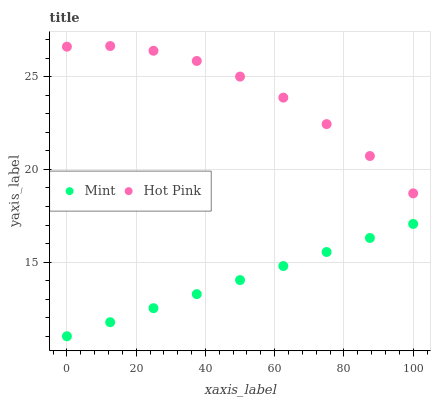Does Mint have the minimum area under the curve?
Answer yes or no. Yes. Does Hot Pink have the maximum area under the curve?
Answer yes or no. Yes. Does Mint have the maximum area under the curve?
Answer yes or no. No. Is Mint the smoothest?
Answer yes or no. Yes. Is Hot Pink the roughest?
Answer yes or no. Yes. Is Mint the roughest?
Answer yes or no. No. Does Mint have the lowest value?
Answer yes or no. Yes. Does Hot Pink have the highest value?
Answer yes or no. Yes. Does Mint have the highest value?
Answer yes or no. No. Is Mint less than Hot Pink?
Answer yes or no. Yes. Is Hot Pink greater than Mint?
Answer yes or no. Yes. Does Mint intersect Hot Pink?
Answer yes or no. No. 